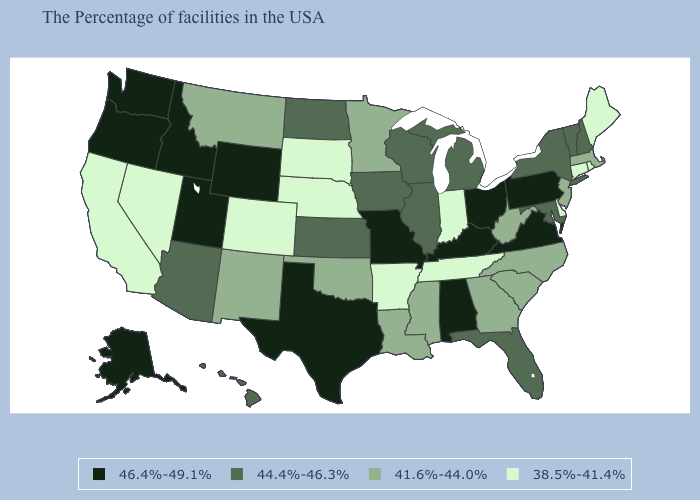What is the value of Washington?
Short answer required. 46.4%-49.1%. What is the highest value in states that border South Dakota?
Quick response, please. 46.4%-49.1%. Which states have the highest value in the USA?
Keep it brief. Pennsylvania, Virginia, Ohio, Kentucky, Alabama, Missouri, Texas, Wyoming, Utah, Idaho, Washington, Oregon, Alaska. Which states have the lowest value in the USA?
Keep it brief. Maine, Rhode Island, Connecticut, Delaware, Indiana, Tennessee, Arkansas, Nebraska, South Dakota, Colorado, Nevada, California. Name the states that have a value in the range 41.6%-44.0%?
Short answer required. Massachusetts, New Jersey, North Carolina, South Carolina, West Virginia, Georgia, Mississippi, Louisiana, Minnesota, Oklahoma, New Mexico, Montana. Does Alaska have the highest value in the USA?
Be succinct. Yes. Does Mississippi have the lowest value in the USA?
Concise answer only. No. What is the highest value in the USA?
Give a very brief answer. 46.4%-49.1%. What is the highest value in the USA?
Be succinct. 46.4%-49.1%. Does Connecticut have a higher value than Montana?
Keep it brief. No. Name the states that have a value in the range 41.6%-44.0%?
Quick response, please. Massachusetts, New Jersey, North Carolina, South Carolina, West Virginia, Georgia, Mississippi, Louisiana, Minnesota, Oklahoma, New Mexico, Montana. Does Indiana have a higher value than Kansas?
Write a very short answer. No. How many symbols are there in the legend?
Give a very brief answer. 4. Among the states that border Rhode Island , which have the highest value?
Quick response, please. Massachusetts. Name the states that have a value in the range 44.4%-46.3%?
Concise answer only. New Hampshire, Vermont, New York, Maryland, Florida, Michigan, Wisconsin, Illinois, Iowa, Kansas, North Dakota, Arizona, Hawaii. 